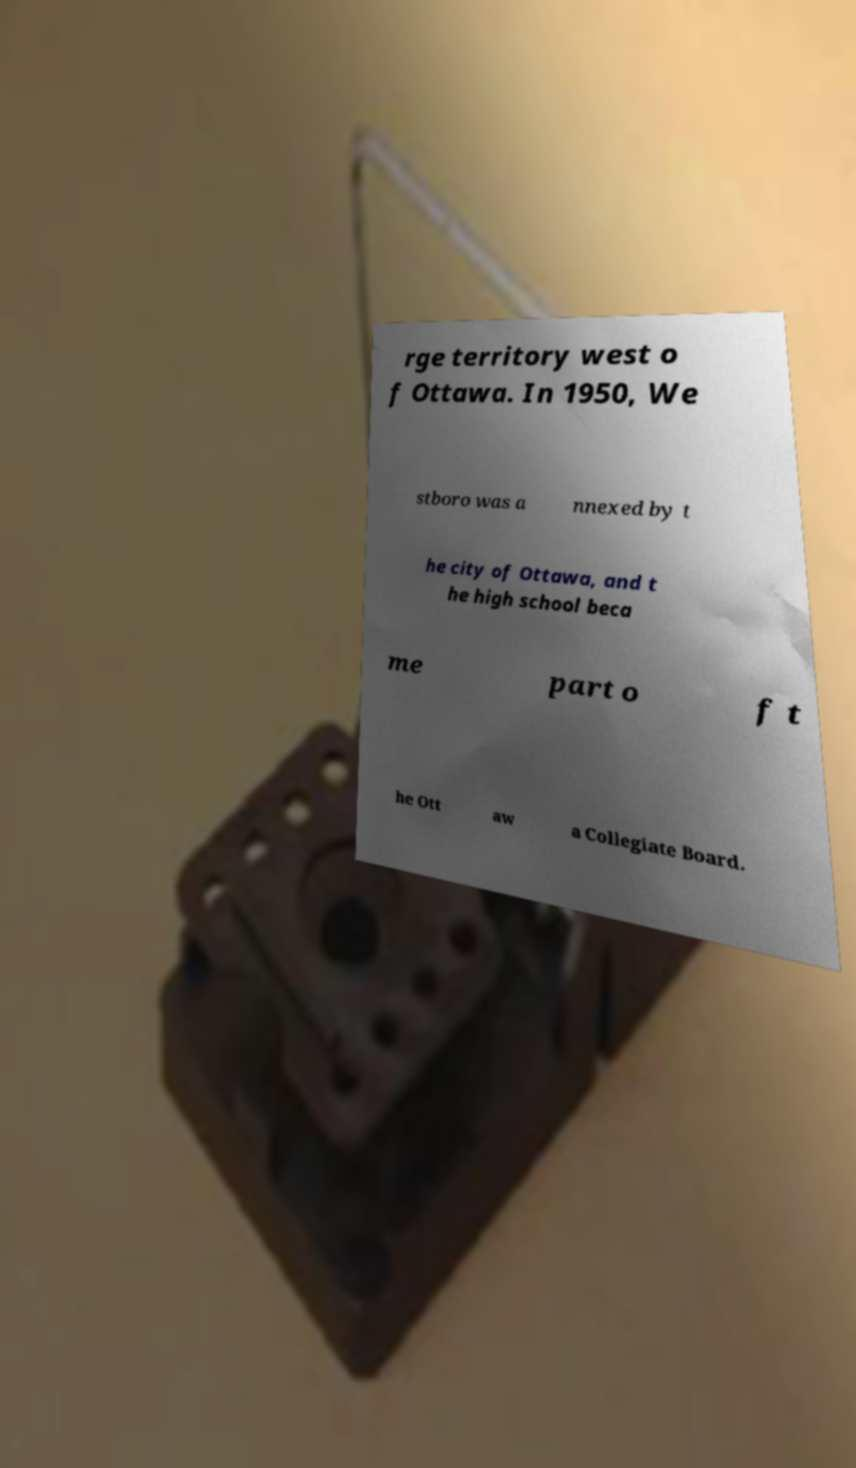Can you read and provide the text displayed in the image?This photo seems to have some interesting text. Can you extract and type it out for me? rge territory west o f Ottawa. In 1950, We stboro was a nnexed by t he city of Ottawa, and t he high school beca me part o f t he Ott aw a Collegiate Board. 